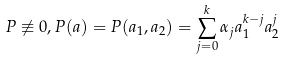Convert formula to latex. <formula><loc_0><loc_0><loc_500><loc_500>P \not \equiv 0 , P ( a ) = P ( a _ { 1 } , a _ { 2 } ) = \sum _ { j = 0 } ^ { k } \alpha _ { j } a _ { 1 } ^ { k - j } a _ { 2 } ^ { j }</formula> 